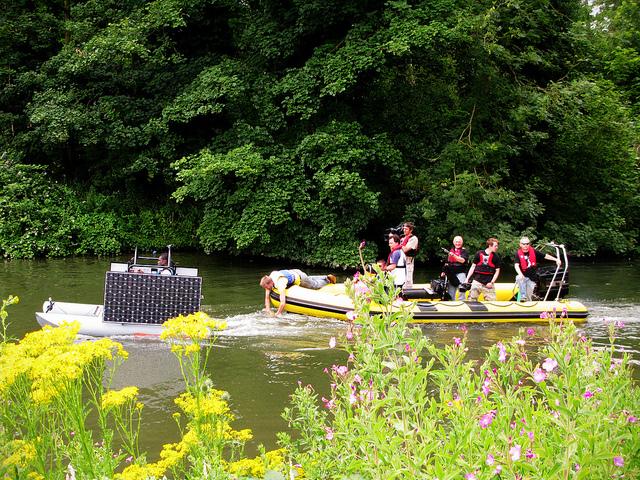How many people are on the boat?
Be succinct. 5. What color are the leaves?
Short answer required. Green. What type of watercraft is that?
Write a very short answer. Raft. 